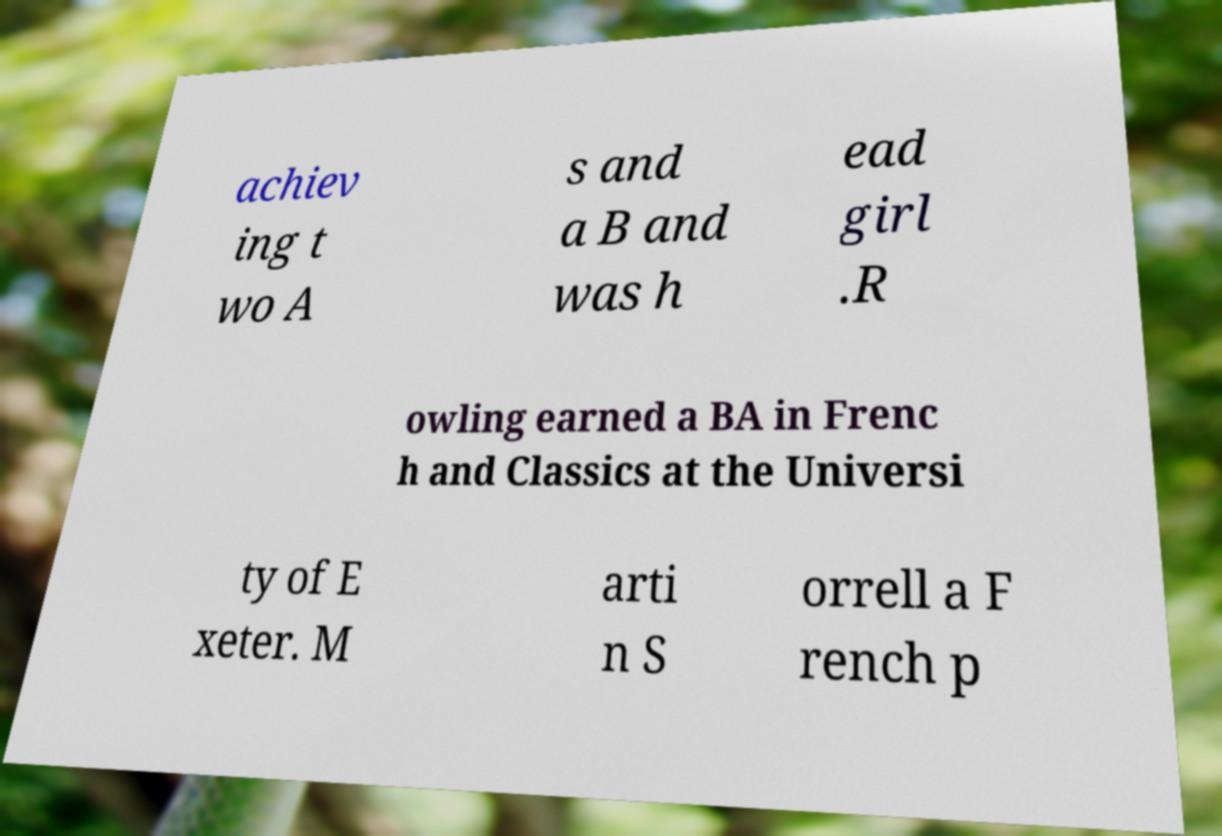Could you extract and type out the text from this image? achiev ing t wo A s and a B and was h ead girl .R owling earned a BA in Frenc h and Classics at the Universi ty of E xeter. M arti n S orrell a F rench p 